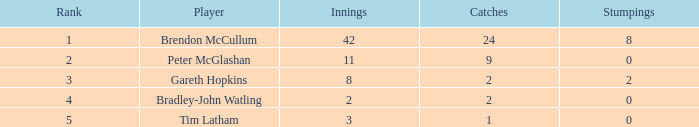How many stumpings did the player Tim Latham have? 0.0. Would you be able to parse every entry in this table? {'header': ['Rank', 'Player', 'Innings', 'Catches', 'Stumpings'], 'rows': [['1', 'Brendon McCullum', '42', '24', '8'], ['2', 'Peter McGlashan', '11', '9', '0'], ['3', 'Gareth Hopkins', '8', '2', '2'], ['4', 'Bradley-John Watling', '2', '2', '0'], ['5', 'Tim Latham', '3', '1', '0']]} 